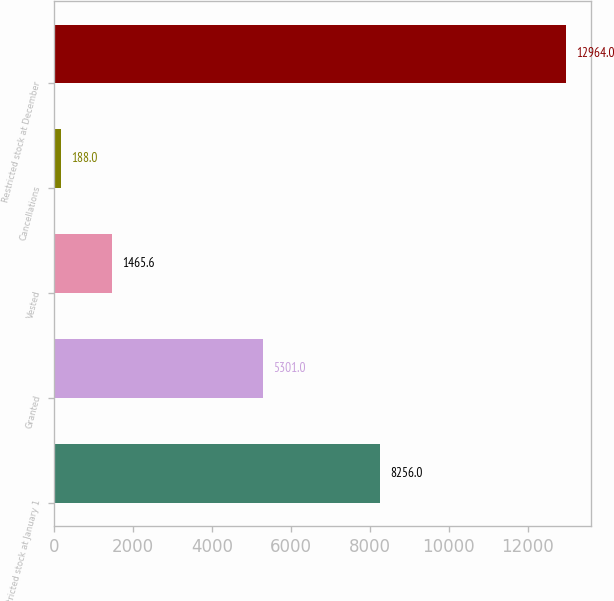<chart> <loc_0><loc_0><loc_500><loc_500><bar_chart><fcel>Restricted stock at January 1<fcel>Granted<fcel>Vested<fcel>Cancellations<fcel>Restricted stock at December<nl><fcel>8256<fcel>5301<fcel>1465.6<fcel>188<fcel>12964<nl></chart> 